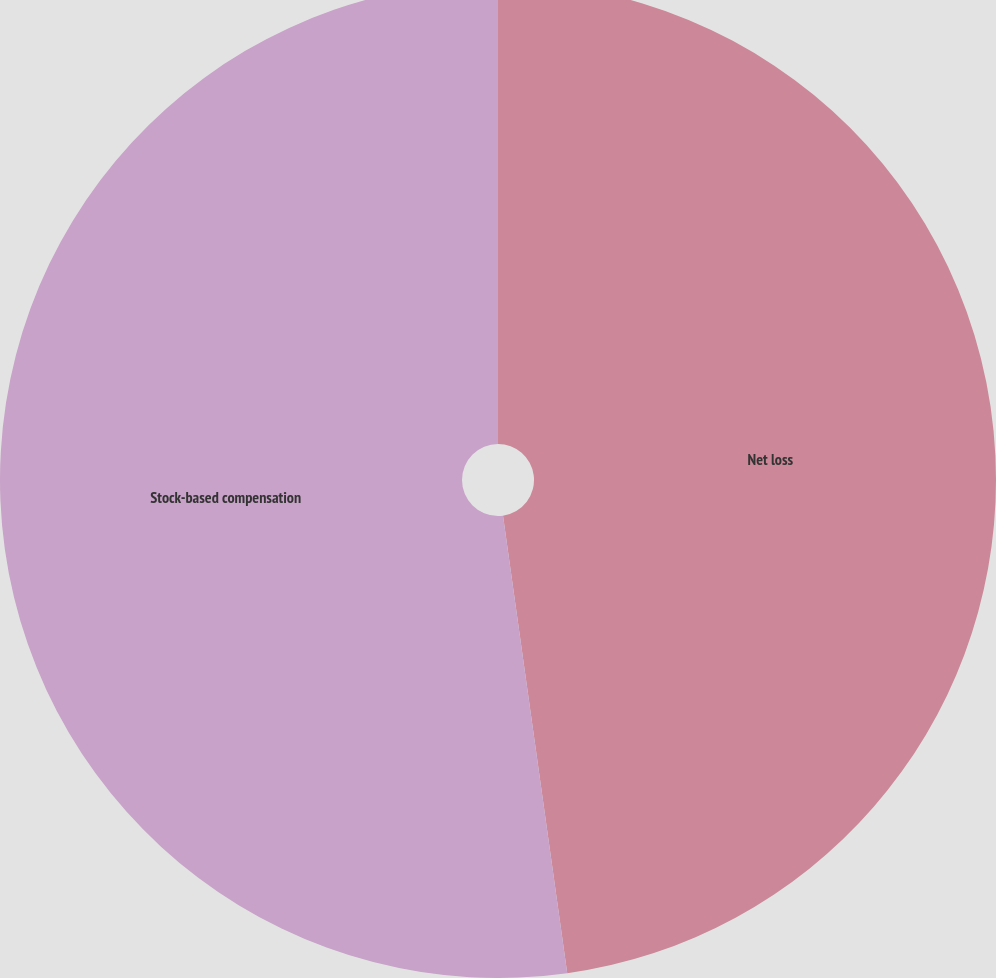<chart> <loc_0><loc_0><loc_500><loc_500><pie_chart><fcel>Net loss<fcel>Stock-based compensation<nl><fcel>47.78%<fcel>52.22%<nl></chart> 